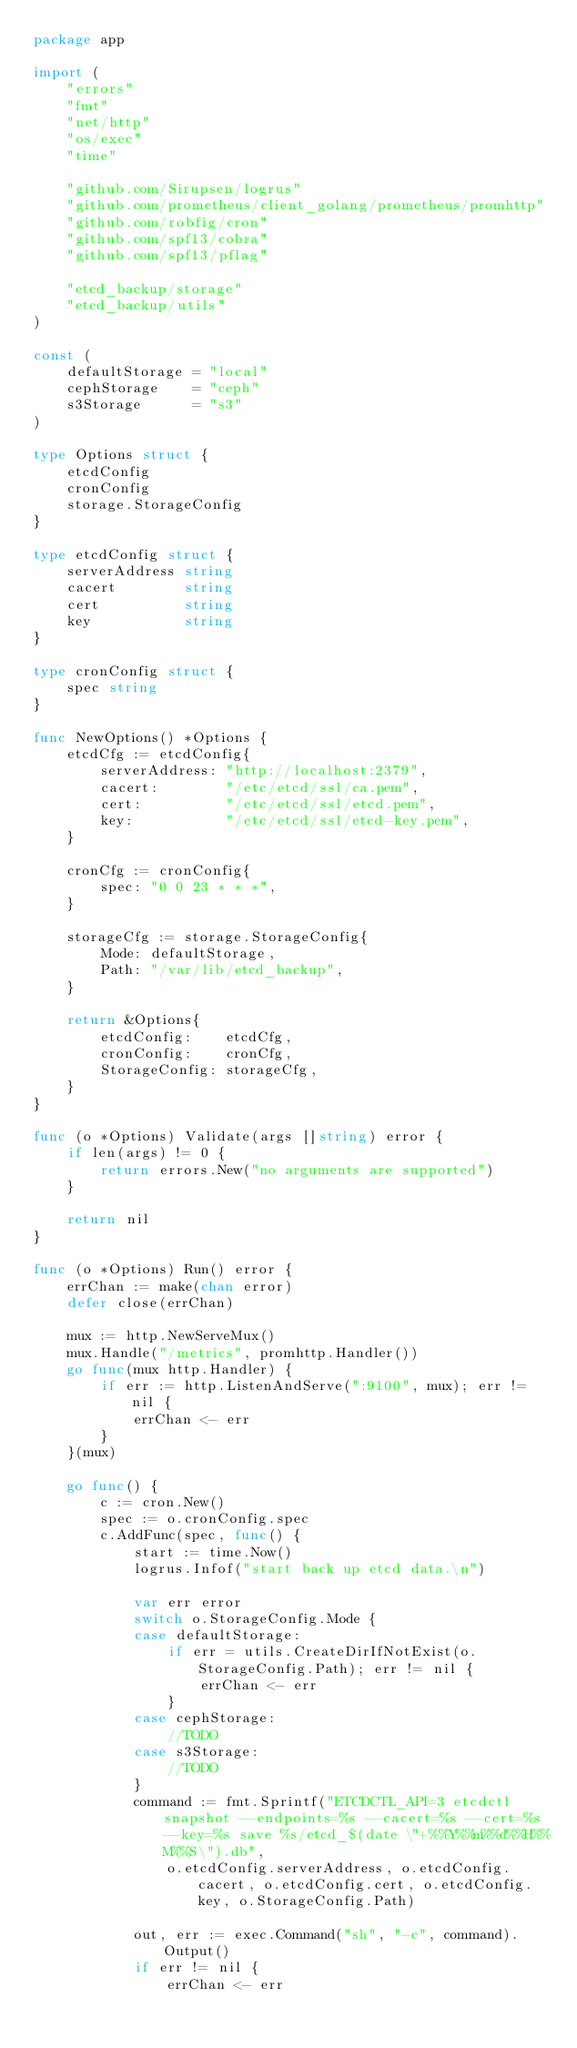<code> <loc_0><loc_0><loc_500><loc_500><_Go_>package app

import (
	"errors"
	"fmt"
	"net/http"
	"os/exec"
	"time"

	"github.com/Sirupsen/logrus"
	"github.com/prometheus/client_golang/prometheus/promhttp"
	"github.com/robfig/cron"
	"github.com/spf13/cobra"
	"github.com/spf13/pflag"

	"etcd_backup/storage"
	"etcd_backup/utils"
)

const (
	defaultStorage = "local"
	cephStorage    = "ceph"
	s3Storage      = "s3"
)

type Options struct {
	etcdConfig
	cronConfig
	storage.StorageConfig
}

type etcdConfig struct {
	serverAddress string
	cacert        string
	cert          string
	key           string
}

type cronConfig struct {
	spec string
}

func NewOptions() *Options {
	etcdCfg := etcdConfig{
		serverAddress: "http://localhost:2379",
		cacert:        "/etc/etcd/ssl/ca.pem",
		cert:          "/etc/etcd/ssl/etcd.pem",
		key:           "/etc/etcd/ssl/etcd-key.pem",
	}

	cronCfg := cronConfig{
		spec: "0 0 23 * * *",
	}

	storageCfg := storage.StorageConfig{
		Mode: defaultStorage,
		Path: "/var/lib/etcd_backup",
	}

	return &Options{
		etcdConfig:    etcdCfg,
		cronConfig:    cronCfg,
		StorageConfig: storageCfg,
	}
}

func (o *Options) Validate(args []string) error {
	if len(args) != 0 {
		return errors.New("no arguments are supported")
	}

	return nil
}

func (o *Options) Run() error {
	errChan := make(chan error)
	defer close(errChan)

	mux := http.NewServeMux()
	mux.Handle("/metrics", promhttp.Handler())
	go func(mux http.Handler) {
		if err := http.ListenAndServe(":9100", mux); err != nil {
			errChan <- err
		}
	}(mux)

	go func() {
		c := cron.New()
		spec := o.cronConfig.spec
		c.AddFunc(spec, func() {
			start := time.Now()
			logrus.Infof("start back up etcd data.\n")

			var err error
			switch o.StorageConfig.Mode {
			case defaultStorage:
				if err = utils.CreateDirIfNotExist(o.StorageConfig.Path); err != nil {
					errChan <- err
				}
			case cephStorage:
				//TODO
			case s3Storage:
				//TODO
			}
			command := fmt.Sprintf("ETCDCTL_API=3 etcdctl snapshot --endpoints=%s --cacert=%s --cert=%s --key=%s save %s/etcd_$(date \"+%%Y%%m%%d%%H%%M%%S\").db",
				o.etcdConfig.serverAddress, o.etcdConfig.cacert, o.etcdConfig.cert, o.etcdConfig.key, o.StorageConfig.Path)

			out, err := exec.Command("sh", "-c", command).Output()
			if err != nil {
				errChan <- err</code> 